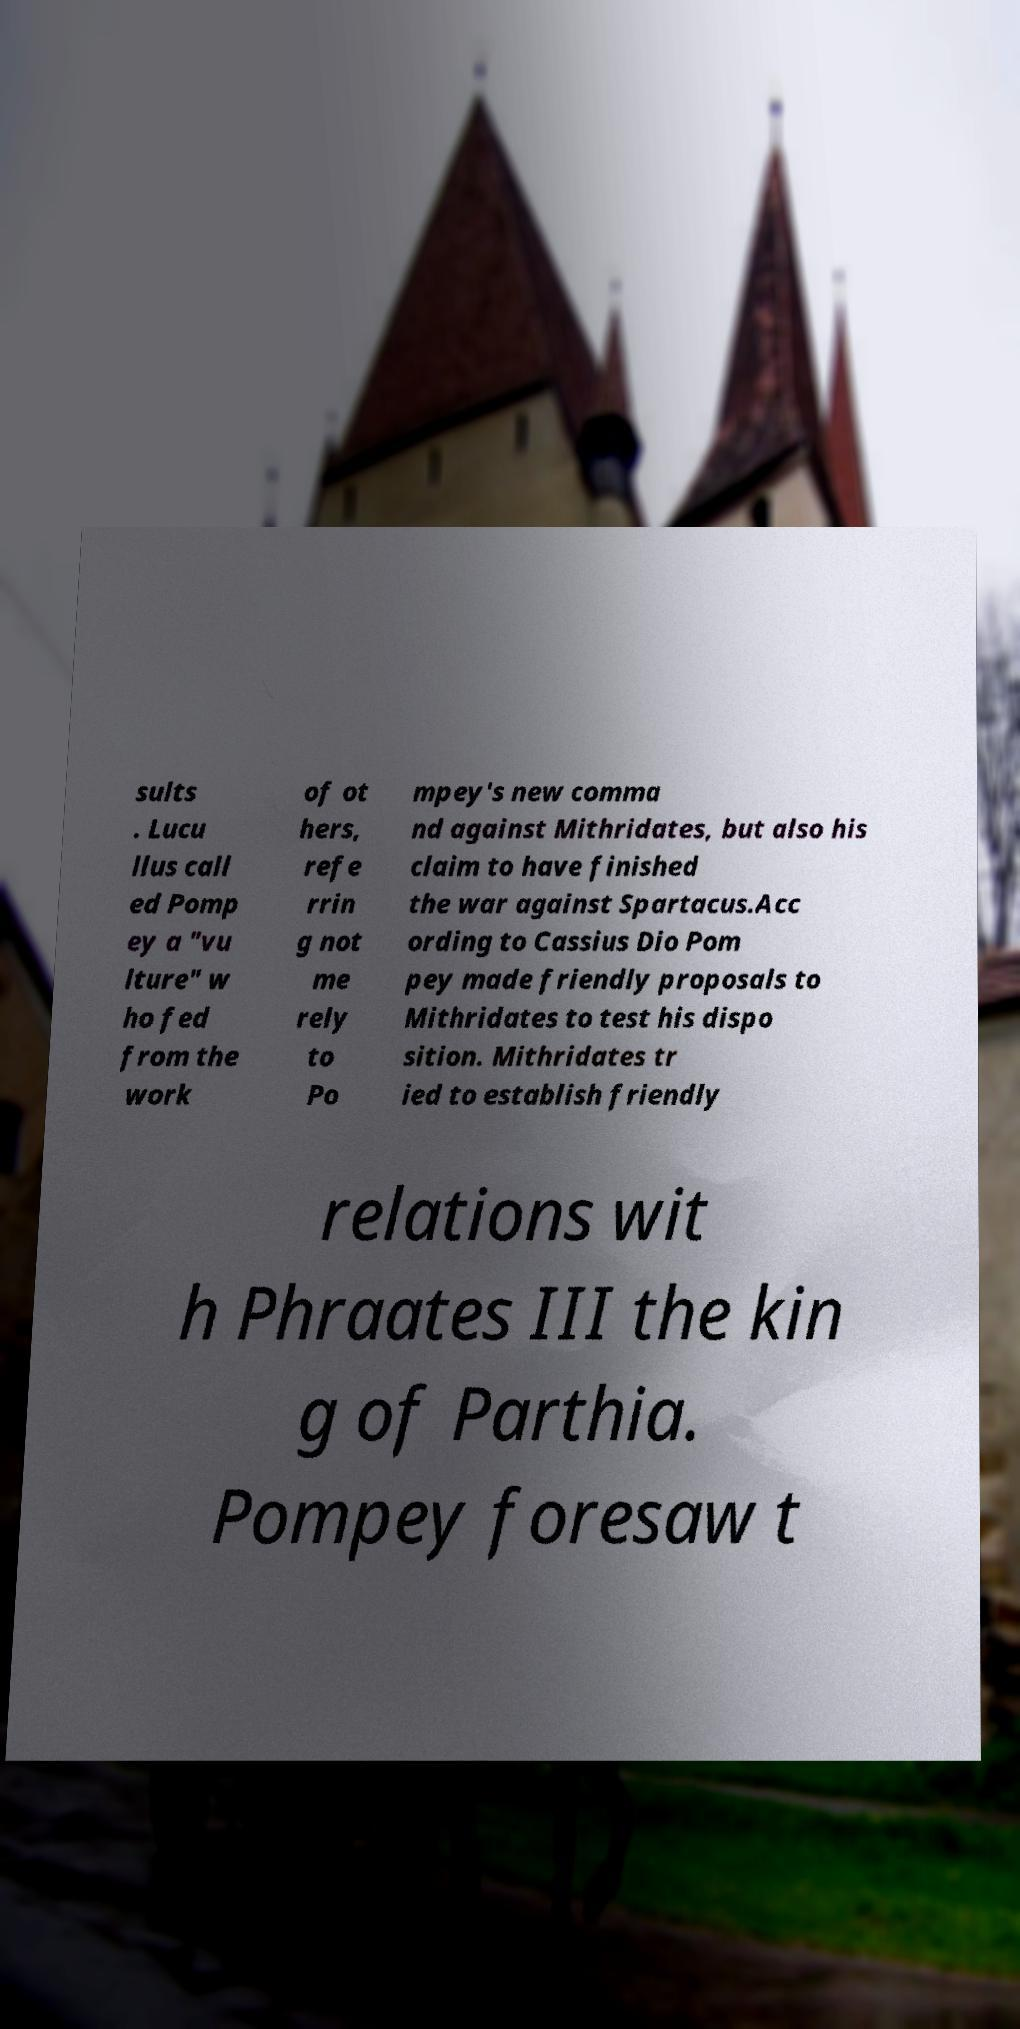Can you read and provide the text displayed in the image?This photo seems to have some interesting text. Can you extract and type it out for me? sults . Lucu llus call ed Pomp ey a "vu lture" w ho fed from the work of ot hers, refe rrin g not me rely to Po mpey's new comma nd against Mithridates, but also his claim to have finished the war against Spartacus.Acc ording to Cassius Dio Pom pey made friendly proposals to Mithridates to test his dispo sition. Mithridates tr ied to establish friendly relations wit h Phraates III the kin g of Parthia. Pompey foresaw t 